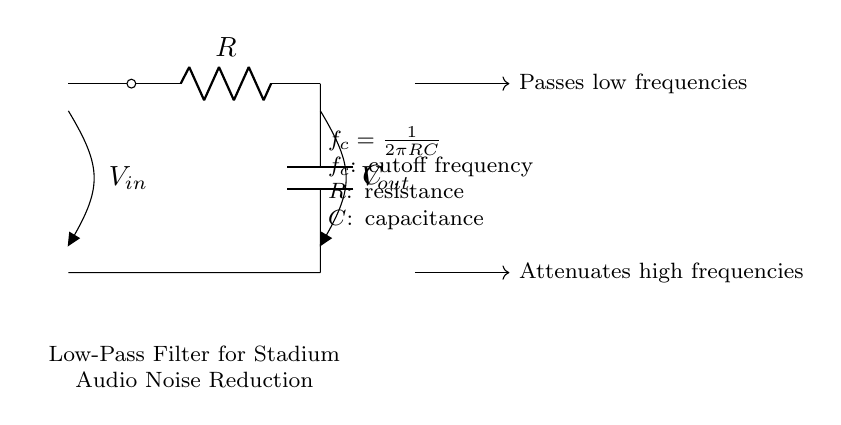What type of filter is represented by this circuit? The circuit includes a resistor and capacitor in series configuration, designed to allow low-frequency signals to pass while attenuating high-frequency noise. This configuration defines it as a low-pass filter.
Answer: Low-pass filter What components are used in the circuit? The circuit comprises a resistor labeled R and a capacitor labeled C, which are standard components used in filtering circuits.
Answer: Resistor and capacitor What does the circuit do to high frequencies? The circuit is designed to attenuate high-frequency signals, meaning that it reduces the amplitude of those signals as they pass through.
Answer: Attenuates What is the cutoff frequency formula for this circuit? The formula provided in the diagram is used to calculate the cutoff frequency for the low-pass filter, defined as \(f_c = \frac{1}{2\pi RC}\).
Answer: f_c = 1/(2πRC) What happens to low frequencies in this circuit? The purpose of this low-pass filter is to allow low frequencies to pass through without significant attenuation, effectively filtering out unwanted high-frequency noise.
Answer: Passes low frequencies What is the effect of increasing the resistance in the circuit? Increasing the resistance will lower the cutoff frequency, meaning that it will allow even lower frequencies to pass and further attenuate more of the high-frequency noise.
Answer: Lowers cutoff frequency What does the symbol Vout indicate in the circuit? The symbol Vout represents the output voltage across the capacitor, which is the voltage that has gone through the low-pass filter after the high frequencies have been attenuated.
Answer: Output voltage 